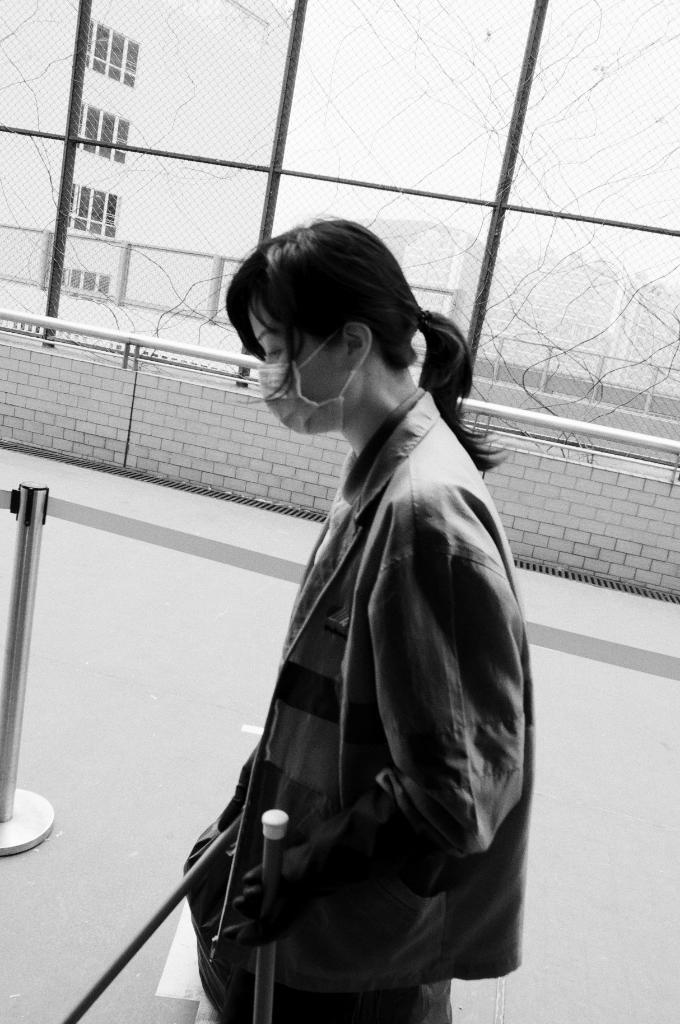Describe this image in one or two sentences. In this image in the center there is one woman who is walking and in the background there is building and wall, and at the bottom there is a walkway. And on the left side there is one iron rod. 